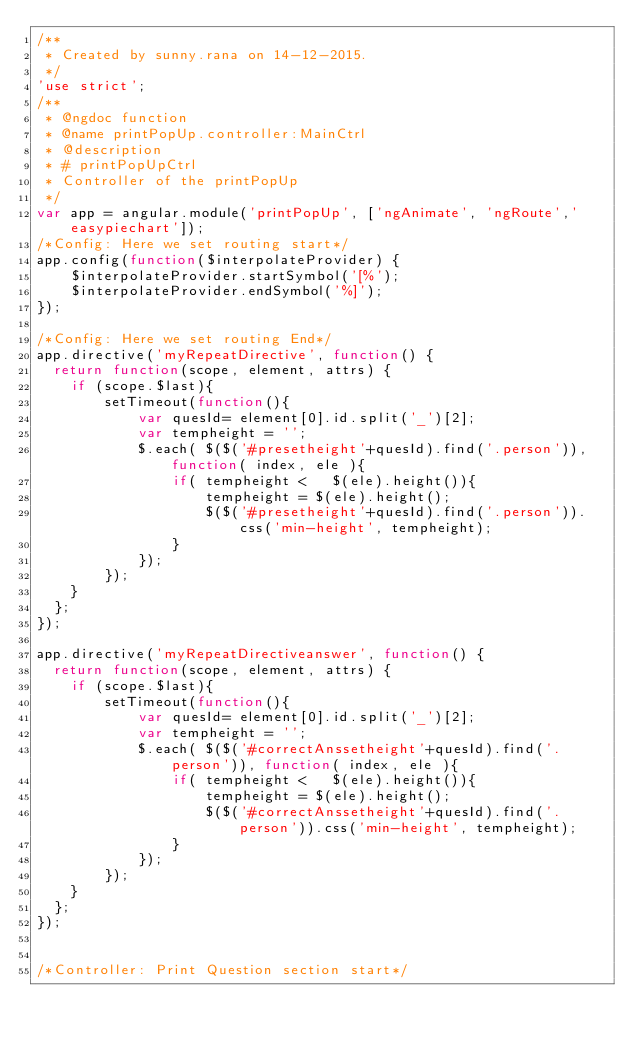<code> <loc_0><loc_0><loc_500><loc_500><_JavaScript_>/**
 * Created by sunny.rana on 14-12-2015.
 */
'use strict';
/**
 * @ngdoc function
 * @name printPopUp.controller:MainCtrl
 * @description
 * # printPopUpCtrl
 * Controller of the printPopUp
 */
var app = angular.module('printPopUp', ['ngAnimate', 'ngRoute','easypiechart']);
/*Config: Here we set routing start*/
app.config(function($interpolateProvider) {
    $interpolateProvider.startSymbol('[%');
    $interpolateProvider.endSymbol('%]');
});

/*Config: Here we set routing End*/
app.directive('myRepeatDirective', function() { 
  return function(scope, element, attrs) {
    if (scope.$last){
        setTimeout(function(){ 
            var quesId= element[0].id.split('_')[2];
            var tempheight = '';
            $.each( $($('#presetheight'+quesId).find('.person')), function( index, ele ){
                if( tempheight <   $(ele).height()){
                    tempheight = $(ele).height();
                    $($('#presetheight'+quesId).find('.person')).css('min-height', tempheight);
                }                
            });            
        });      
    }
  };
});

app.directive('myRepeatDirectiveanswer', function() { 
  return function(scope, element, attrs) {
    if (scope.$last){
        setTimeout(function(){ 
            var quesId= element[0].id.split('_')[2];
            var tempheight = '';
            $.each( $($('#correctAnssetheight'+quesId).find('.person')), function( index, ele ){
                if( tempheight <   $(ele).height()){
                    tempheight = $(ele).height();
                    $($('#correctAnssetheight'+quesId).find('.person')).css('min-height', tempheight);
                }                
            });            
        });      
    }
  };
});


/*Controller: Print Question section start*/</code> 